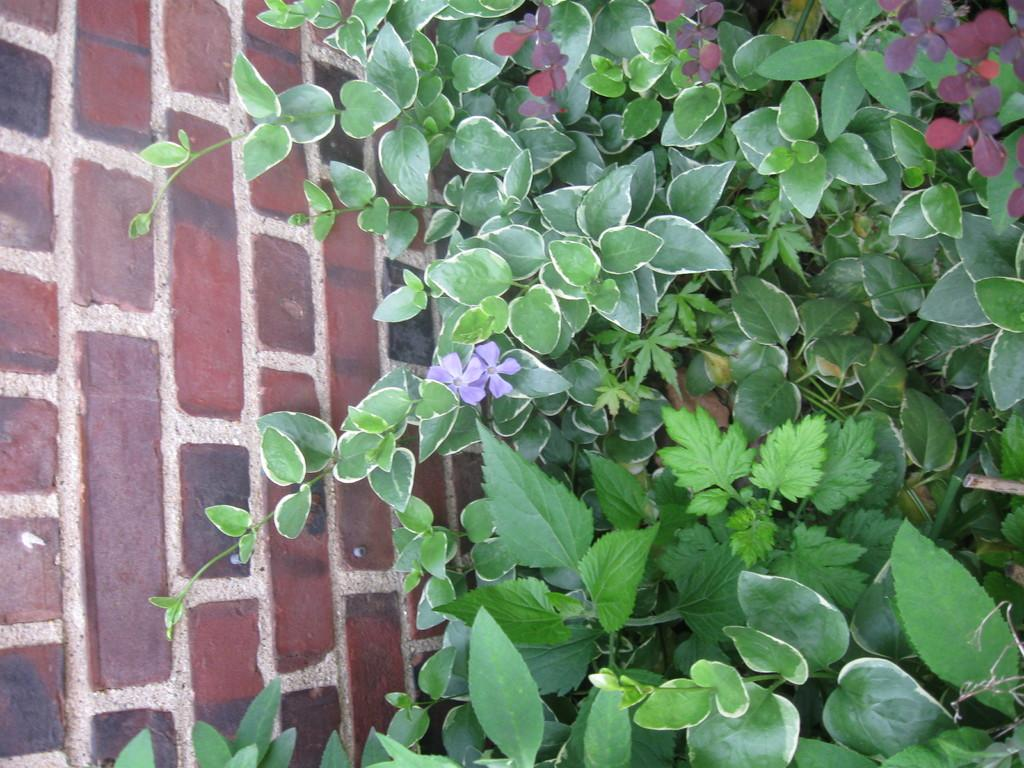What celestial bodies are depicted in the picture? There are planets in the picture. What type of structure is present in the picture? There is a brick wall in the picture. What is the condition of the plant in the picture? The plant in the picture has flowers. What type of school uniform can be seen on the planet in the image? There is no school or uniform present in the image; it features planets and a brick wall. 